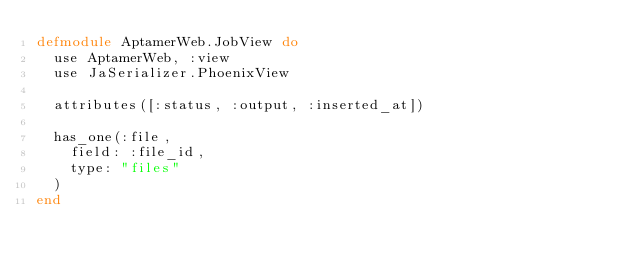Convert code to text. <code><loc_0><loc_0><loc_500><loc_500><_Elixir_>defmodule AptamerWeb.JobView do
  use AptamerWeb, :view
  use JaSerializer.PhoenixView

  attributes([:status, :output, :inserted_at])

  has_one(:file,
    field: :file_id,
    type: "files"
  )
end
</code> 